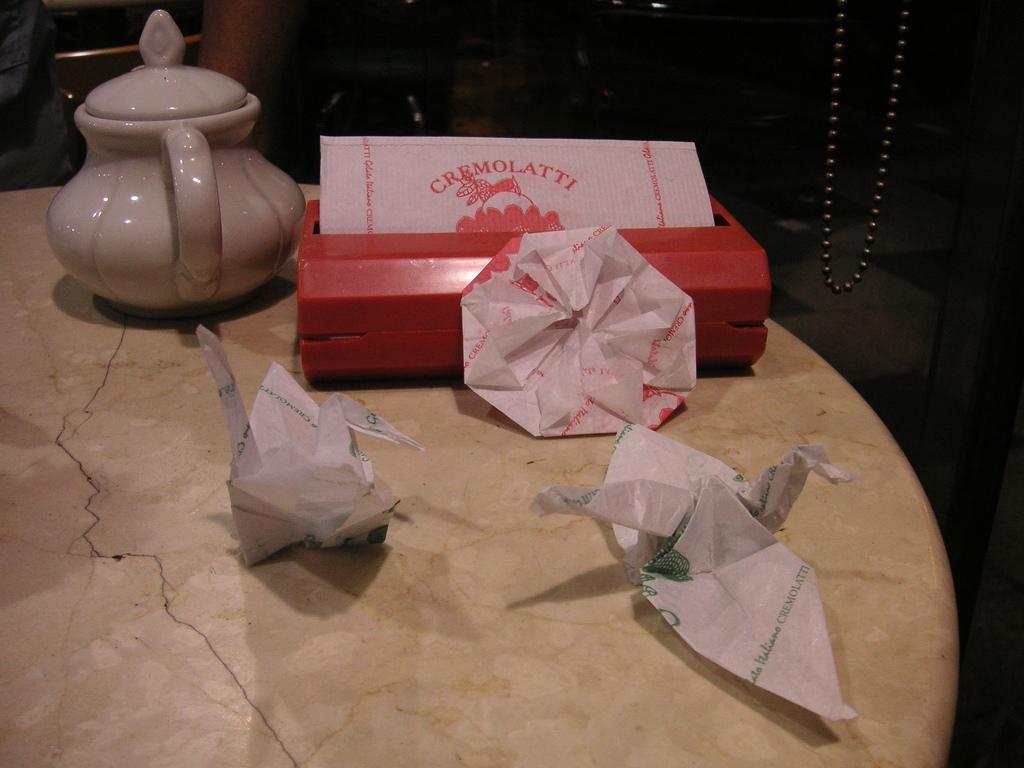Please provide a concise description of this image. In this image I can see a cream colour table and on it I can see few napkins, a red colour tissue box and on the left side of this image I can see a white colour cattle. I can also see a black colour thing on the right side of this image. 